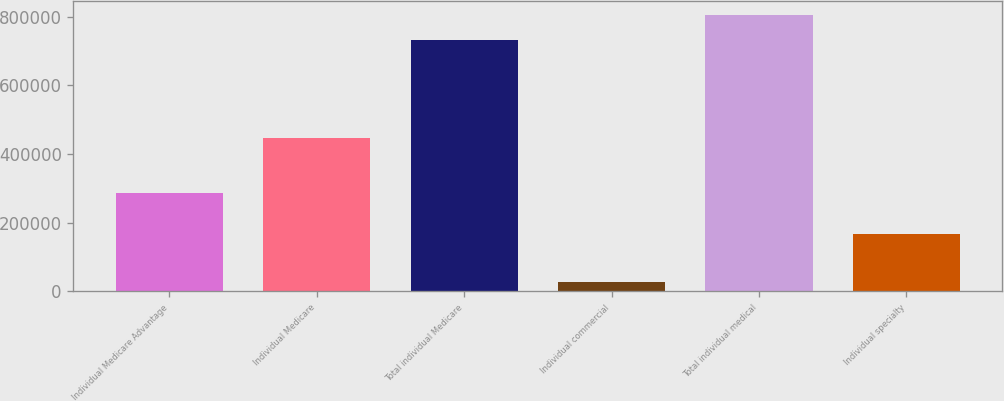Convert chart to OTSL. <chart><loc_0><loc_0><loc_500><loc_500><bar_chart><fcel>Individual Medicare Advantage<fcel>Individual Medicare<fcel>Total individual Medicare<fcel>Individual commercial<fcel>Total individual medical<fcel>Individual specialty<nl><fcel>287300<fcel>445200<fcel>732500<fcel>28200<fcel>805750<fcel>166200<nl></chart> 